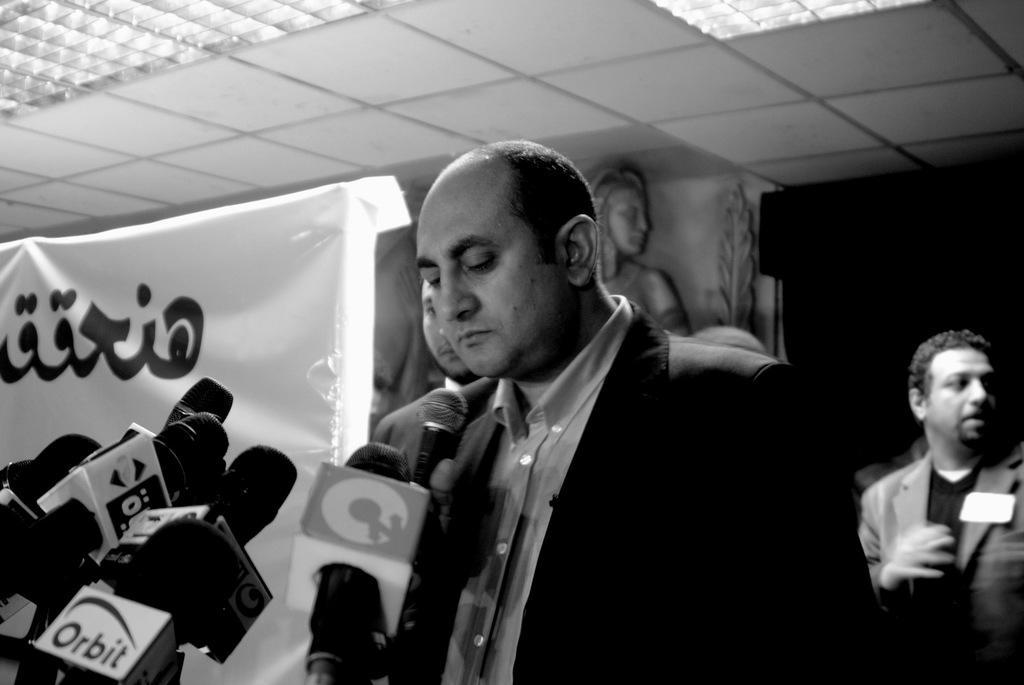Describe this image in one or two sentences. In this image there are miles, a person standing , and in the background there are two persons standing,banner, sculptures, lights, ceiling, wall. 